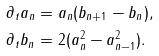Convert formula to latex. <formula><loc_0><loc_0><loc_500><loc_500>\partial _ { t } a _ { n } & = a _ { n } ( b _ { n + 1 } - b _ { n } ) , \\ \partial _ { t } b _ { n } & = 2 ( a _ { n } ^ { 2 } - a _ { n - 1 } ^ { 2 } ) .</formula> 